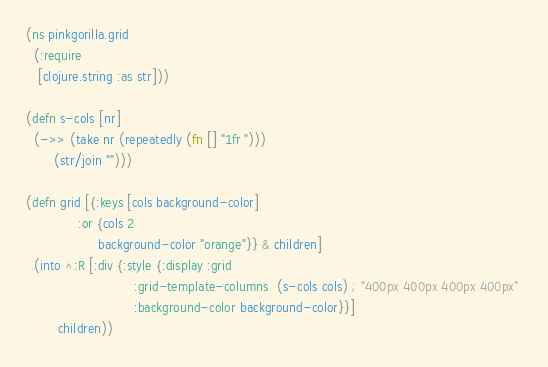<code> <loc_0><loc_0><loc_500><loc_500><_Clojure_>(ns pinkgorilla.grid
  (:require
   [clojure.string :as str]))

(defn s-cols [nr]
  (->> (take nr (repeatedly (fn [] "1fr ")))
       (str/join "")))

(defn grid [{:keys [cols background-color]
             :or {cols 2
                  background-color "orange"}} & children]
  (into ^:R [:div {:style {:display :grid
                           :grid-template-columns  (s-cols cols) ; "400px 400px 400px 400px" 
                           :background-color background-color}}]
        children))

</code> 